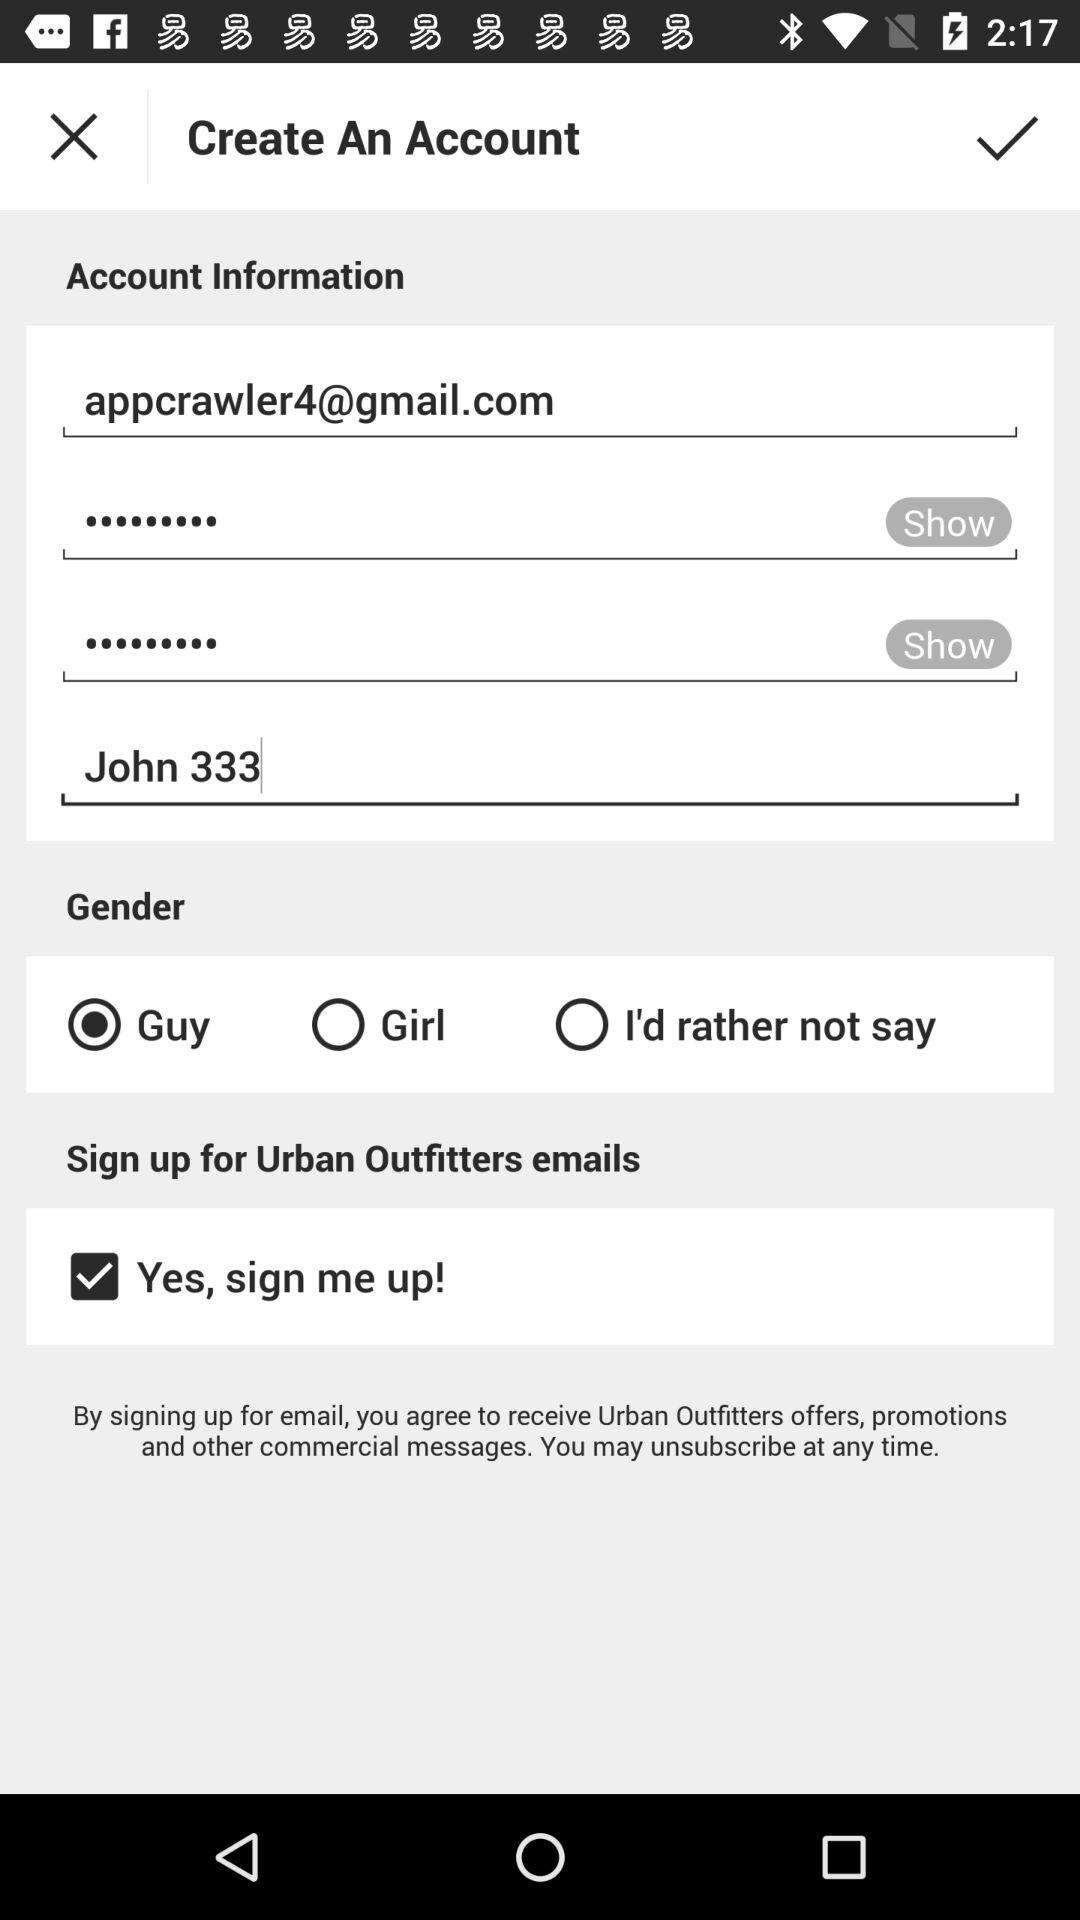Can we show password?
When the provided information is insufficient, respond with <no answer>. <no answer> 